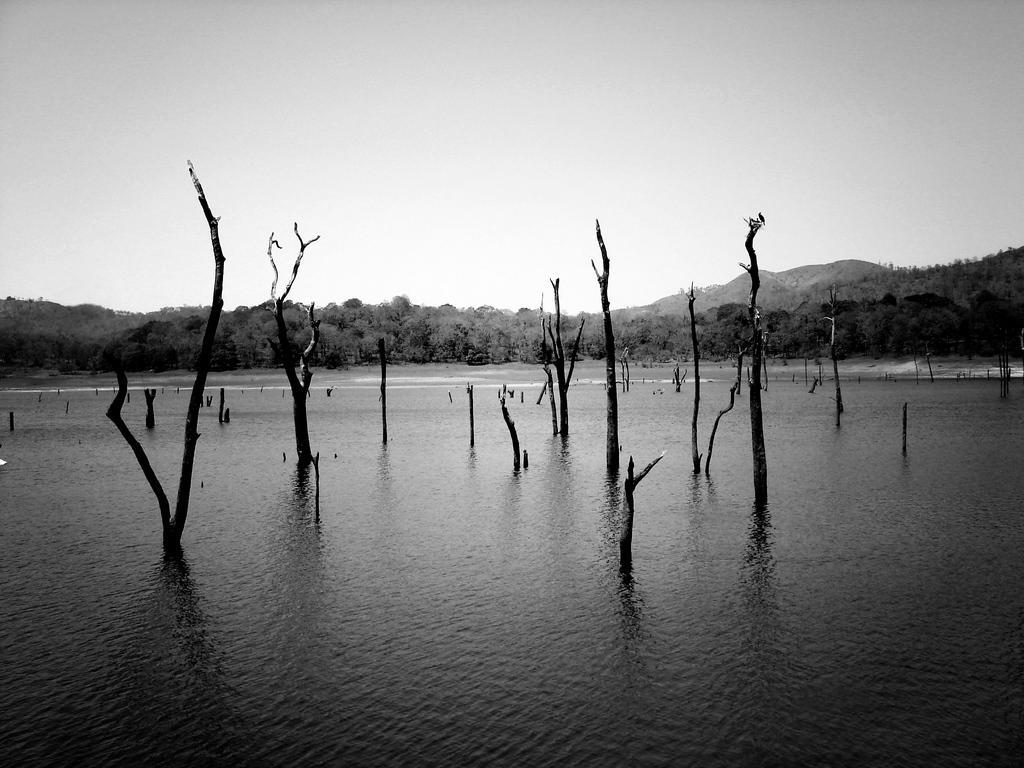In one or two sentences, can you explain what this image depicts? In this picture we can see few trees in the water, in the background we can find few hills, and it is a black and white photography. 